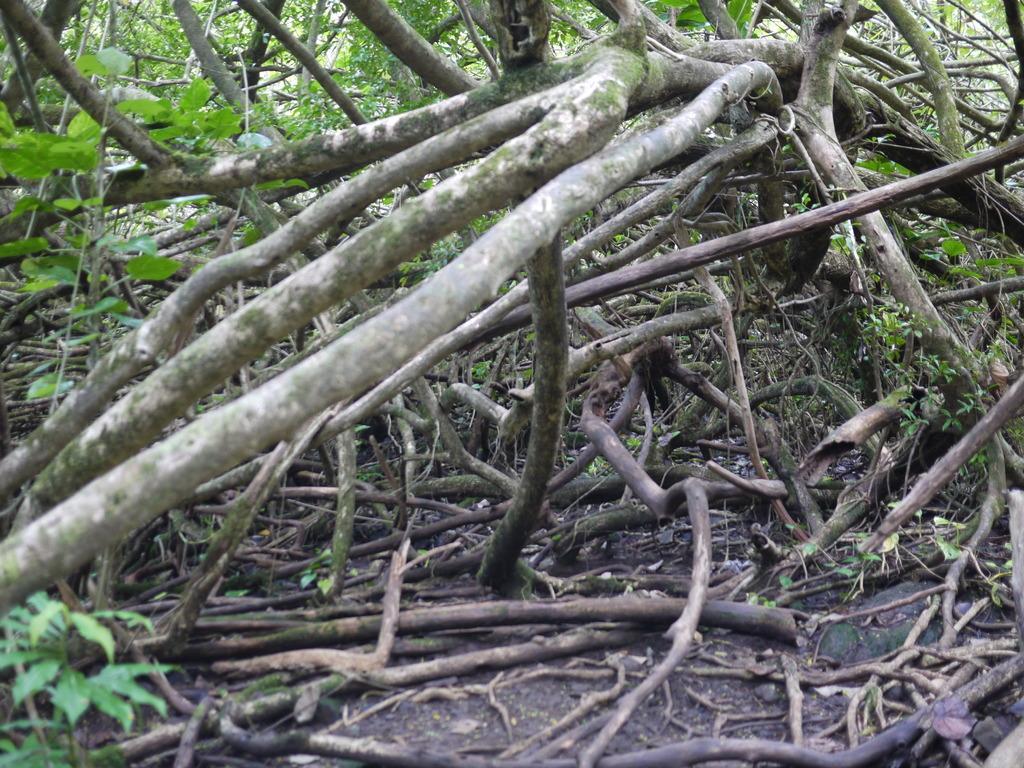How would you summarize this image in a sentence or two? In the foreground of the image we can see wood logs placed on the ground. In the center of the image we can see the branches of a tree. In the background, we can see trees and some plants. 